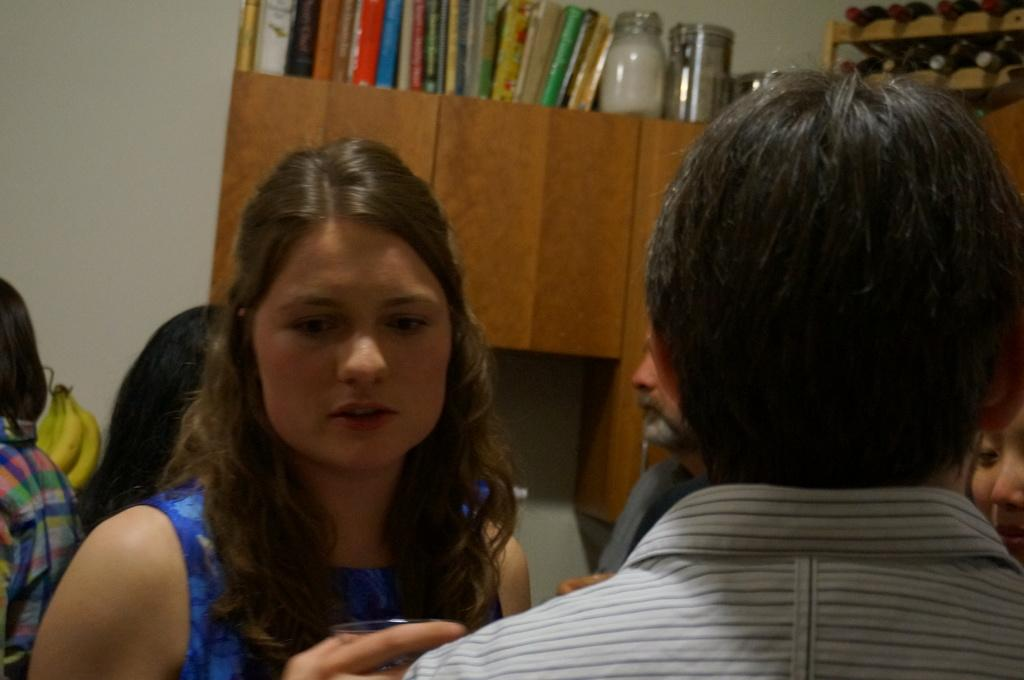<image>
Relay a brief, clear account of the picture shown. Several people stand below a cabinet with books on top of it, one being "The Joy of Cooking." 